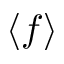Convert formula to latex. <formula><loc_0><loc_0><loc_500><loc_500>\langle f \rangle</formula> 